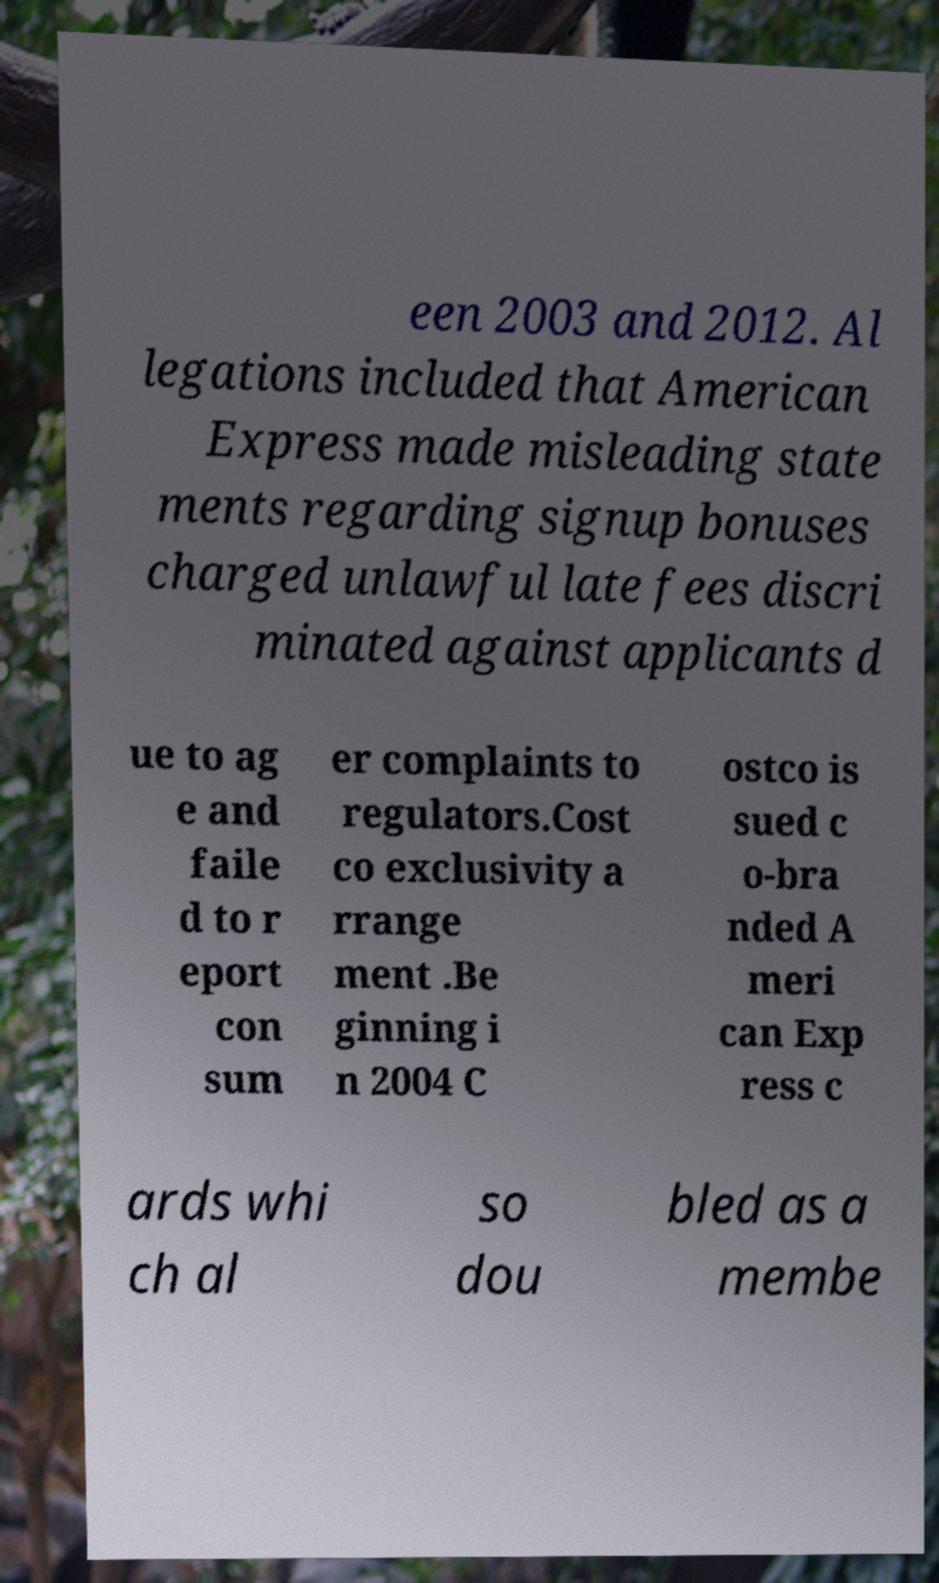Could you assist in decoding the text presented in this image and type it out clearly? een 2003 and 2012. Al legations included that American Express made misleading state ments regarding signup bonuses charged unlawful late fees discri minated against applicants d ue to ag e and faile d to r eport con sum er complaints to regulators.Cost co exclusivity a rrange ment .Be ginning i n 2004 C ostco is sued c o-bra nded A meri can Exp ress c ards whi ch al so dou bled as a membe 